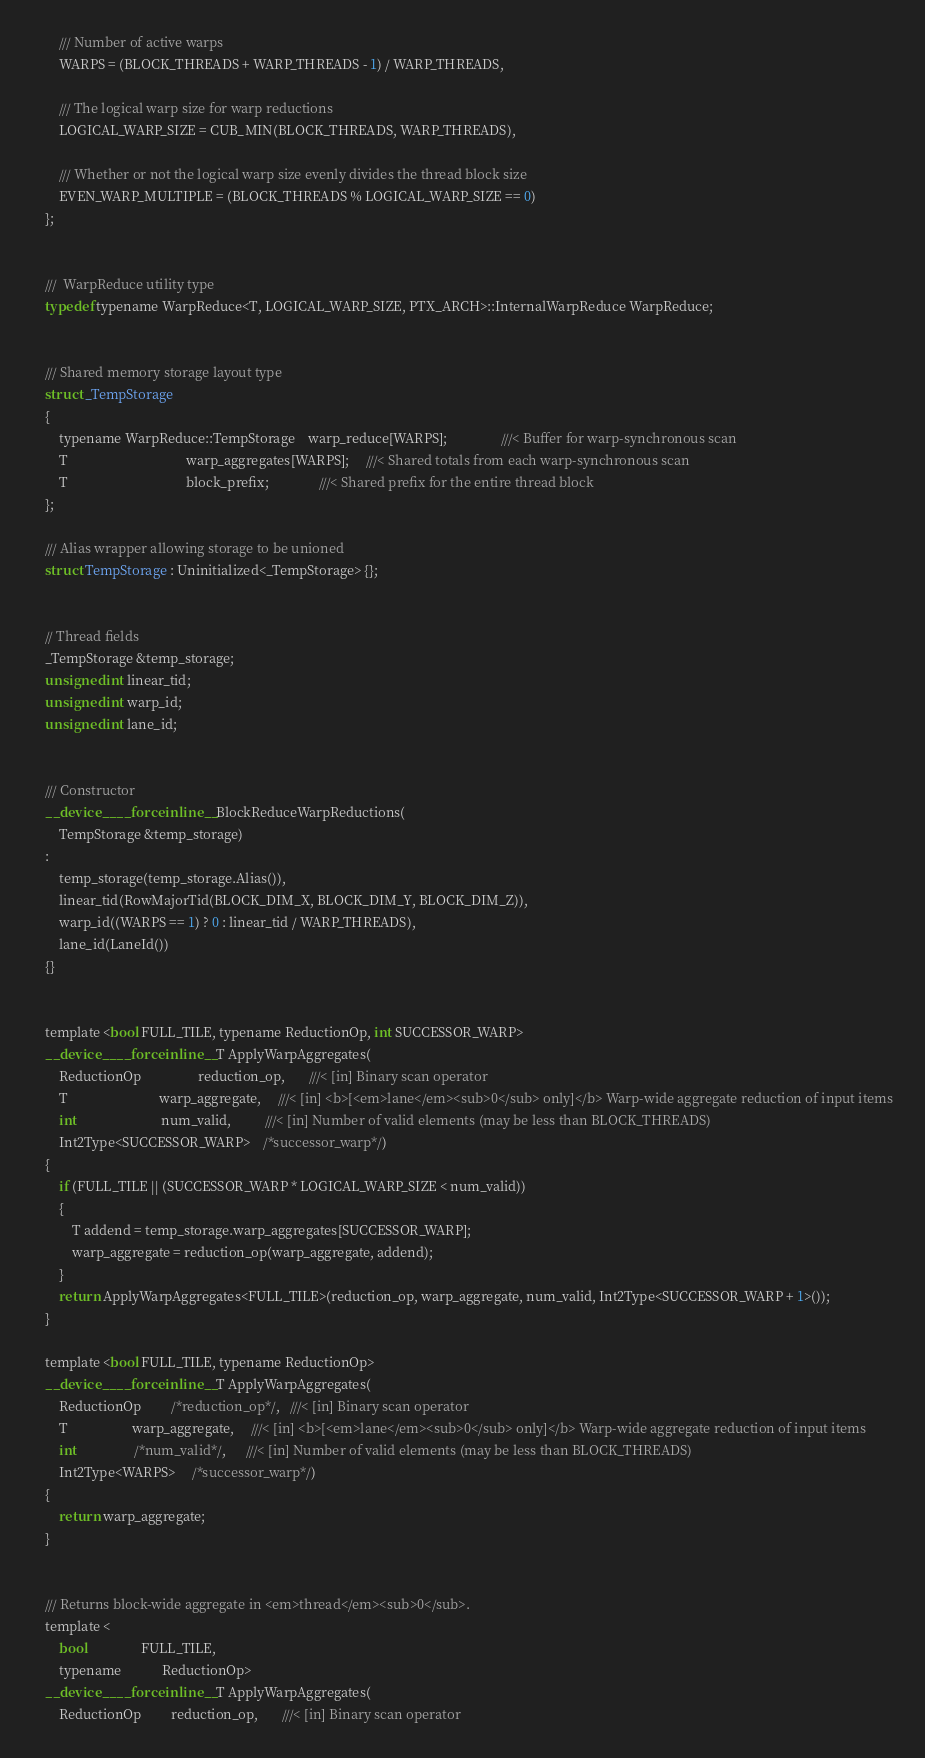<code> <loc_0><loc_0><loc_500><loc_500><_Cuda_>        /// Number of active warps
        WARPS = (BLOCK_THREADS + WARP_THREADS - 1) / WARP_THREADS,

        /// The logical warp size for warp reductions
        LOGICAL_WARP_SIZE = CUB_MIN(BLOCK_THREADS, WARP_THREADS),

        /// Whether or not the logical warp size evenly divides the thread block size
        EVEN_WARP_MULTIPLE = (BLOCK_THREADS % LOGICAL_WARP_SIZE == 0)
    };


    ///  WarpReduce utility type
    typedef typename WarpReduce<T, LOGICAL_WARP_SIZE, PTX_ARCH>::InternalWarpReduce WarpReduce;


    /// Shared memory storage layout type
    struct _TempStorage
    {
        typename WarpReduce::TempStorage    warp_reduce[WARPS];                ///< Buffer for warp-synchronous scan
        T                                   warp_aggregates[WARPS];     ///< Shared totals from each warp-synchronous scan
        T                                   block_prefix;               ///< Shared prefix for the entire thread block
    };

    /// Alias wrapper allowing storage to be unioned
    struct TempStorage : Uninitialized<_TempStorage> {};


    // Thread fields
    _TempStorage &temp_storage;
    unsigned int linear_tid;
    unsigned int warp_id;
    unsigned int lane_id;


    /// Constructor
    __device__ __forceinline__ BlockReduceWarpReductions(
        TempStorage &temp_storage)
    :
        temp_storage(temp_storage.Alias()),
        linear_tid(RowMajorTid(BLOCK_DIM_X, BLOCK_DIM_Y, BLOCK_DIM_Z)),
        warp_id((WARPS == 1) ? 0 : linear_tid / WARP_THREADS),
        lane_id(LaneId())
    {}


    template <bool FULL_TILE, typename ReductionOp, int SUCCESSOR_WARP>
    __device__ __forceinline__ T ApplyWarpAggregates(
        ReductionOp                 reduction_op,       ///< [in] Binary scan operator
        T                           warp_aggregate,     ///< [in] <b>[<em>lane</em><sub>0</sub> only]</b> Warp-wide aggregate reduction of input items
        int                         num_valid,          ///< [in] Number of valid elements (may be less than BLOCK_THREADS)
        Int2Type<SUCCESSOR_WARP>    /*successor_warp*/)
    {
        if (FULL_TILE || (SUCCESSOR_WARP * LOGICAL_WARP_SIZE < num_valid))
        {
            T addend = temp_storage.warp_aggregates[SUCCESSOR_WARP];
            warp_aggregate = reduction_op(warp_aggregate, addend);
        }
        return ApplyWarpAggregates<FULL_TILE>(reduction_op, warp_aggregate, num_valid, Int2Type<SUCCESSOR_WARP + 1>());
    }

    template <bool FULL_TILE, typename ReductionOp>
    __device__ __forceinline__ T ApplyWarpAggregates(
        ReductionOp         /*reduction_op*/,   ///< [in] Binary scan operator
        T                   warp_aggregate,     ///< [in] <b>[<em>lane</em><sub>0</sub> only]</b> Warp-wide aggregate reduction of input items
        int                 /*num_valid*/,      ///< [in] Number of valid elements (may be less than BLOCK_THREADS)
        Int2Type<WARPS>     /*successor_warp*/)
    {
        return warp_aggregate;
    }


    /// Returns block-wide aggregate in <em>thread</em><sub>0</sub>.
    template <
        bool                FULL_TILE,
        typename            ReductionOp>
    __device__ __forceinline__ T ApplyWarpAggregates(
        ReductionOp         reduction_op,       ///< [in] Binary scan operator</code> 